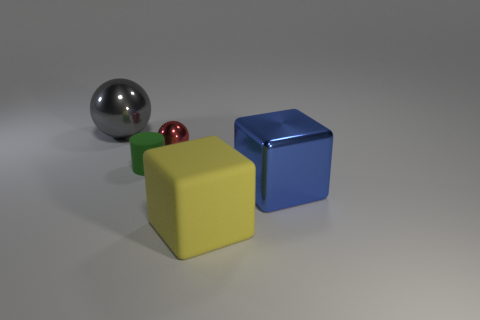Add 4 tiny spheres. How many objects exist? 9 Subtract 1 spheres. How many spheres are left? 1 Subtract all gray cylinders. How many red cubes are left? 0 Subtract all tiny matte cylinders. Subtract all yellow blocks. How many objects are left? 3 Add 4 green rubber cylinders. How many green rubber cylinders are left? 5 Add 4 tiny metallic objects. How many tiny metallic objects exist? 5 Subtract 1 blue blocks. How many objects are left? 4 Subtract all spheres. How many objects are left? 3 Subtract all red cylinders. Subtract all green blocks. How many cylinders are left? 1 